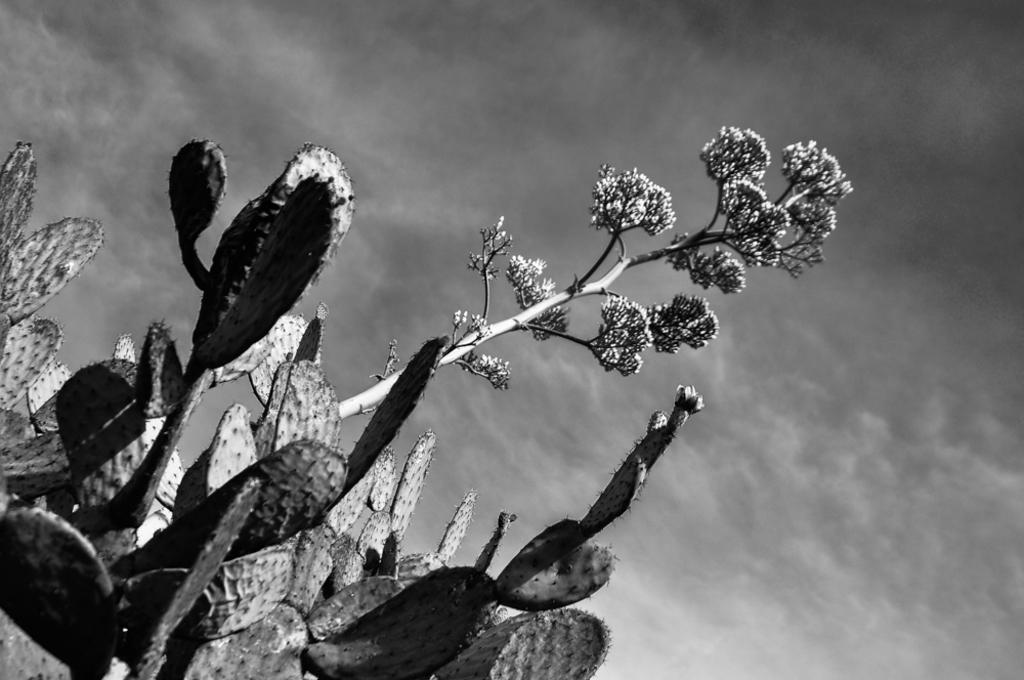What is the color scheme of the image? The image is black and white. What type of plant can be seen in the image? There is a cactus in the image, and another plant is also present. What can be seen in the background of the image? The sky is visible in the background of the image. What is the condition of the sky in the image? Clouds are present in the sky. How many friends are sitting around the fire in the image? There are no friends or fire present in the image; it features a cactus, another plant, and a sky with clouds. What type of system is being used to control the plants in the image? There is no system controlling the plants in the image; they are simply growing in their natural environment. 